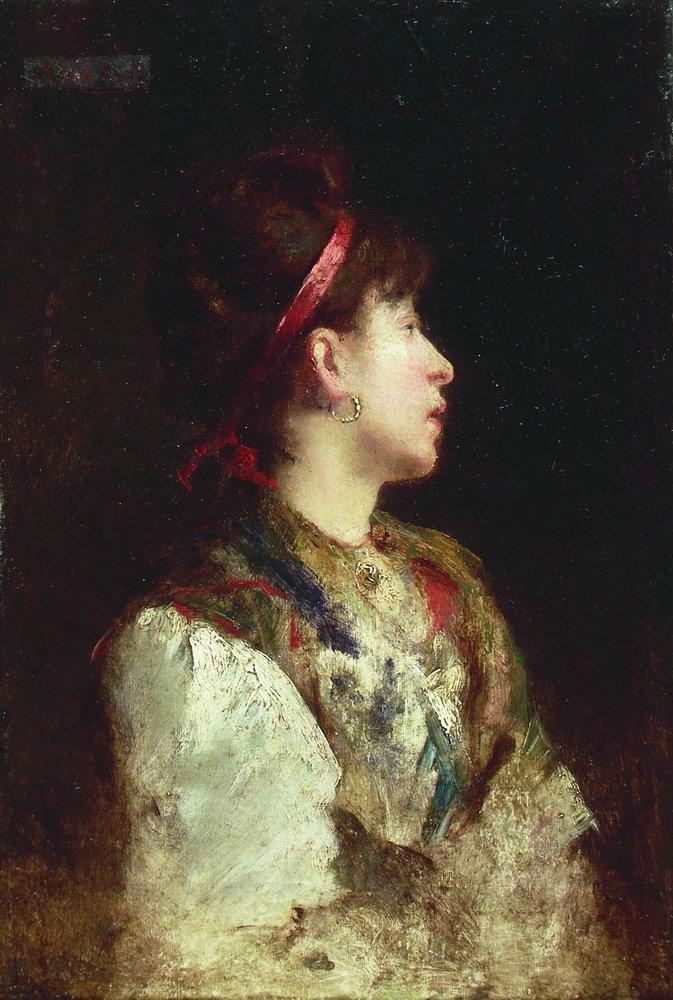Let's play a game. If this woman was transported to modern times, how would she adapt? If Annaliese were transported to modern times, she would initially be bewildered by the hustle and bustle of contemporary life. However, her adaptable and artistic nature would quickly come to the fore. She might become a revered fashion designer, drawing inspiration from both her 19th-century roots and modern styles. The shawls she once wove by hand would be transformed into high fashion pieces, adored by many. Her keen introspection would allow her to navigate and perhaps even influence modern cultural movements, bringing a touch of timeless elegance to the fast-paced world. 